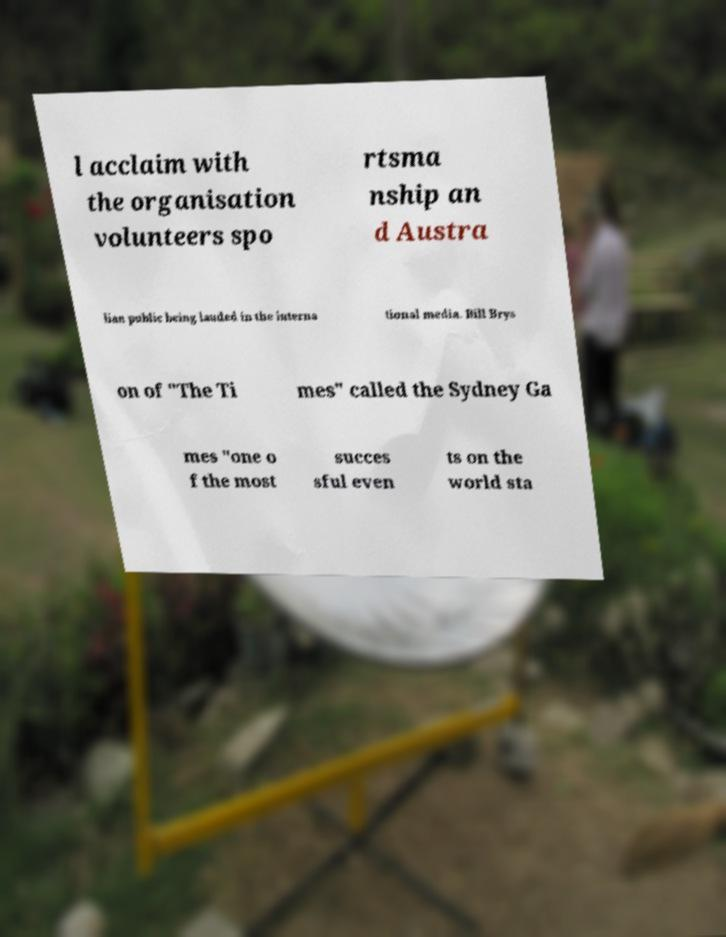Please read and relay the text visible in this image. What does it say? l acclaim with the organisation volunteers spo rtsma nship an d Austra lian public being lauded in the interna tional media. Bill Brys on of "The Ti mes" called the Sydney Ga mes "one o f the most succes sful even ts on the world sta 